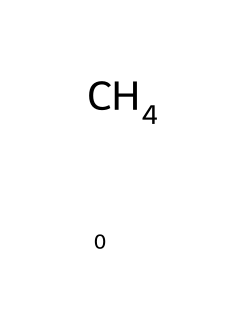What is the name of this chemical? The chemical represented by the SMILES "C" is methane, which consists of one carbon atom bonded to four hydrogen atoms.
Answer: methane How many hydrogen atoms are in this molecule? The SMILES representation "C" indicates one carbon atom, which is surrounded by four hydrogen atoms. Therefore, the answer is derived from the bonding structure of methane.
Answer: four What type of bond does methane primarily contain? Methane has single covalent bonds between the carbon atom and each of the four hydrogen atoms, indicated by the arrangement of the atoms in the structure.
Answer: covalent What is the molecular formula of methane? The SMILES "C" corresponds to the molecular formula CH₄, which signifies one carbon atom and four hydrogen atoms bond together.
Answer: CH4 Is methane flammable? Methane is a simple hydrocarbon (alkane) that is known to be highly flammable due to the presence of carbon and hydrogen, which readily react in combustion.
Answer: yes What is the primary use of methane? Methane is commonly used as a fuel source, particularly in heating and electricity generation, owing to its high energy content and efficiency.
Answer: fuel 